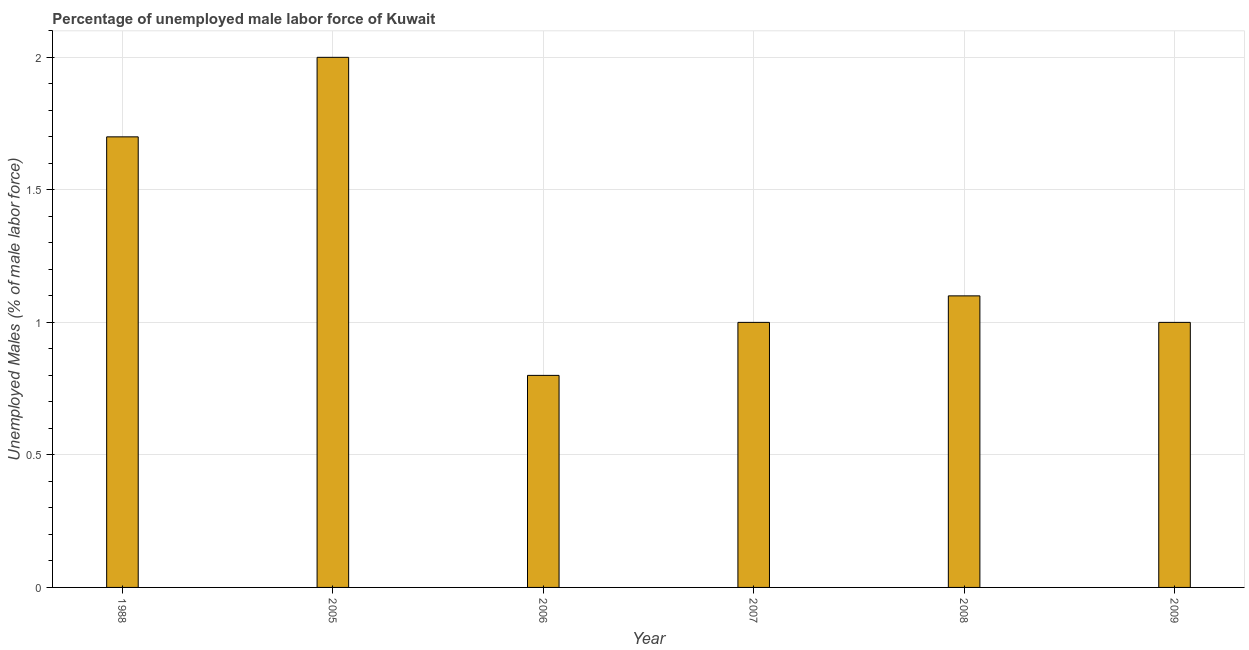Does the graph contain any zero values?
Give a very brief answer. No. Does the graph contain grids?
Ensure brevity in your answer.  Yes. What is the title of the graph?
Make the answer very short. Percentage of unemployed male labor force of Kuwait. What is the label or title of the X-axis?
Your answer should be compact. Year. What is the label or title of the Y-axis?
Your response must be concise. Unemployed Males (% of male labor force). What is the total unemployed male labour force in 2006?
Give a very brief answer. 0.8. Across all years, what is the maximum total unemployed male labour force?
Make the answer very short. 2. Across all years, what is the minimum total unemployed male labour force?
Provide a succinct answer. 0.8. In which year was the total unemployed male labour force minimum?
Keep it short and to the point. 2006. What is the sum of the total unemployed male labour force?
Keep it short and to the point. 7.6. What is the difference between the total unemployed male labour force in 2006 and 2008?
Offer a terse response. -0.3. What is the average total unemployed male labour force per year?
Give a very brief answer. 1.27. What is the median total unemployed male labour force?
Give a very brief answer. 1.05. Do a majority of the years between 2009 and 2007 (inclusive) have total unemployed male labour force greater than 0.8 %?
Offer a terse response. Yes. What is the ratio of the total unemployed male labour force in 1988 to that in 2006?
Ensure brevity in your answer.  2.12. Is the sum of the total unemployed male labour force in 2006 and 2008 greater than the maximum total unemployed male labour force across all years?
Keep it short and to the point. No. What is the difference between the highest and the lowest total unemployed male labour force?
Provide a short and direct response. 1.2. How many bars are there?
Ensure brevity in your answer.  6. How many years are there in the graph?
Make the answer very short. 6. What is the Unemployed Males (% of male labor force) in 1988?
Ensure brevity in your answer.  1.7. What is the Unemployed Males (% of male labor force) of 2006?
Offer a terse response. 0.8. What is the Unemployed Males (% of male labor force) in 2008?
Keep it short and to the point. 1.1. What is the difference between the Unemployed Males (% of male labor force) in 1988 and 2007?
Provide a short and direct response. 0.7. What is the difference between the Unemployed Males (% of male labor force) in 2005 and 2006?
Give a very brief answer. 1.2. What is the difference between the Unemployed Males (% of male labor force) in 2005 and 2007?
Offer a very short reply. 1. What is the difference between the Unemployed Males (% of male labor force) in 2005 and 2008?
Ensure brevity in your answer.  0.9. What is the difference between the Unemployed Males (% of male labor force) in 2006 and 2007?
Offer a very short reply. -0.2. What is the difference between the Unemployed Males (% of male labor force) in 2006 and 2009?
Provide a short and direct response. -0.2. What is the ratio of the Unemployed Males (% of male labor force) in 1988 to that in 2006?
Your response must be concise. 2.12. What is the ratio of the Unemployed Males (% of male labor force) in 1988 to that in 2007?
Your answer should be very brief. 1.7. What is the ratio of the Unemployed Males (% of male labor force) in 1988 to that in 2008?
Your answer should be very brief. 1.54. What is the ratio of the Unemployed Males (% of male labor force) in 2005 to that in 2007?
Your response must be concise. 2. What is the ratio of the Unemployed Males (% of male labor force) in 2005 to that in 2008?
Offer a very short reply. 1.82. What is the ratio of the Unemployed Males (% of male labor force) in 2006 to that in 2007?
Provide a short and direct response. 0.8. What is the ratio of the Unemployed Males (% of male labor force) in 2006 to that in 2008?
Your answer should be very brief. 0.73. What is the ratio of the Unemployed Males (% of male labor force) in 2007 to that in 2008?
Give a very brief answer. 0.91. What is the ratio of the Unemployed Males (% of male labor force) in 2007 to that in 2009?
Keep it short and to the point. 1. What is the ratio of the Unemployed Males (% of male labor force) in 2008 to that in 2009?
Offer a very short reply. 1.1. 